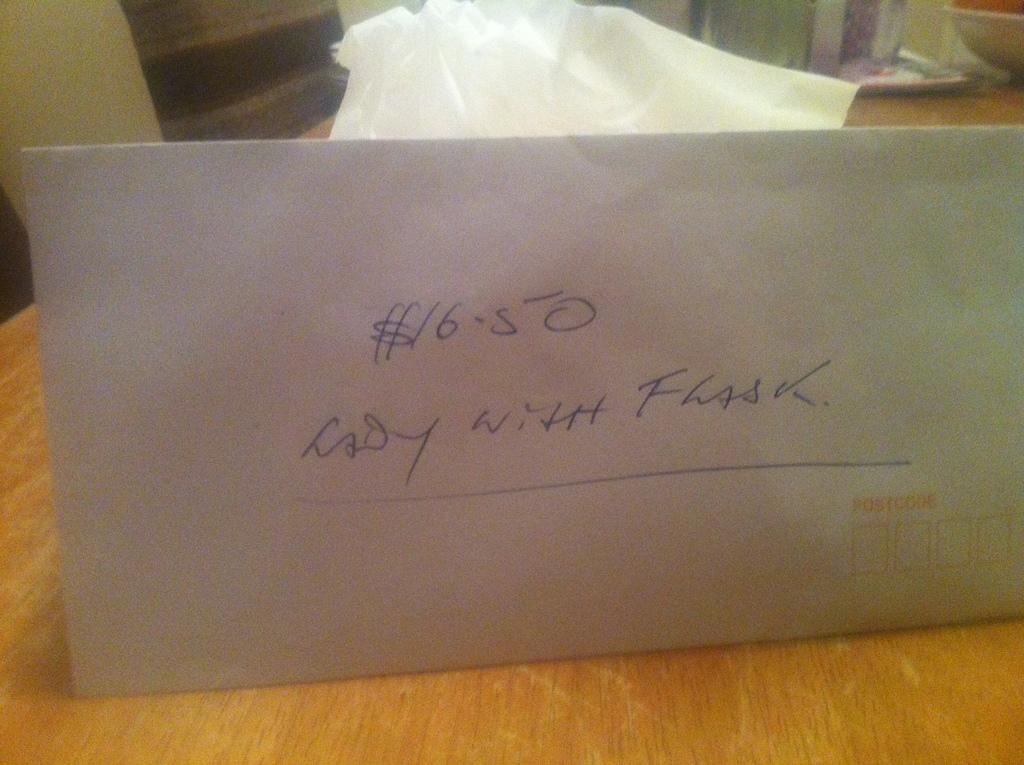What does the lady have?
Keep it short and to the point. Flask. What amount is written on envelope?
Provide a succinct answer. $16.50. 